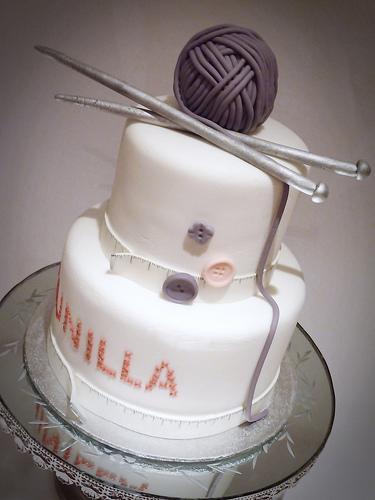How many buttons are on the cake?
Give a very brief answer. 3. How many cakes are in the photo?
Give a very brief answer. 1. 